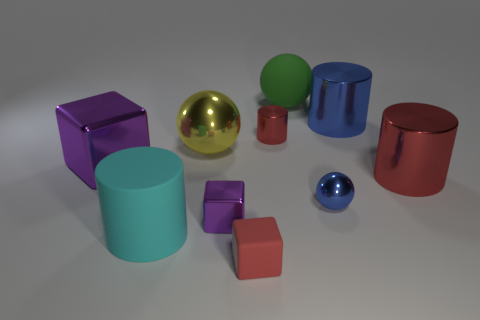Subtract 1 cylinders. How many cylinders are left? 3 Subtract all cubes. How many objects are left? 7 Add 8 red metallic things. How many red metallic things are left? 10 Add 6 large yellow metal things. How many large yellow metal things exist? 7 Subtract 0 yellow cubes. How many objects are left? 10 Subtract all brown metallic cubes. Subtract all small blue metallic things. How many objects are left? 9 